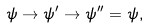<formula> <loc_0><loc_0><loc_500><loc_500>\psi \rightarrow \psi ^ { \prime } \rightarrow \psi ^ { \prime \prime } = \psi ,</formula> 